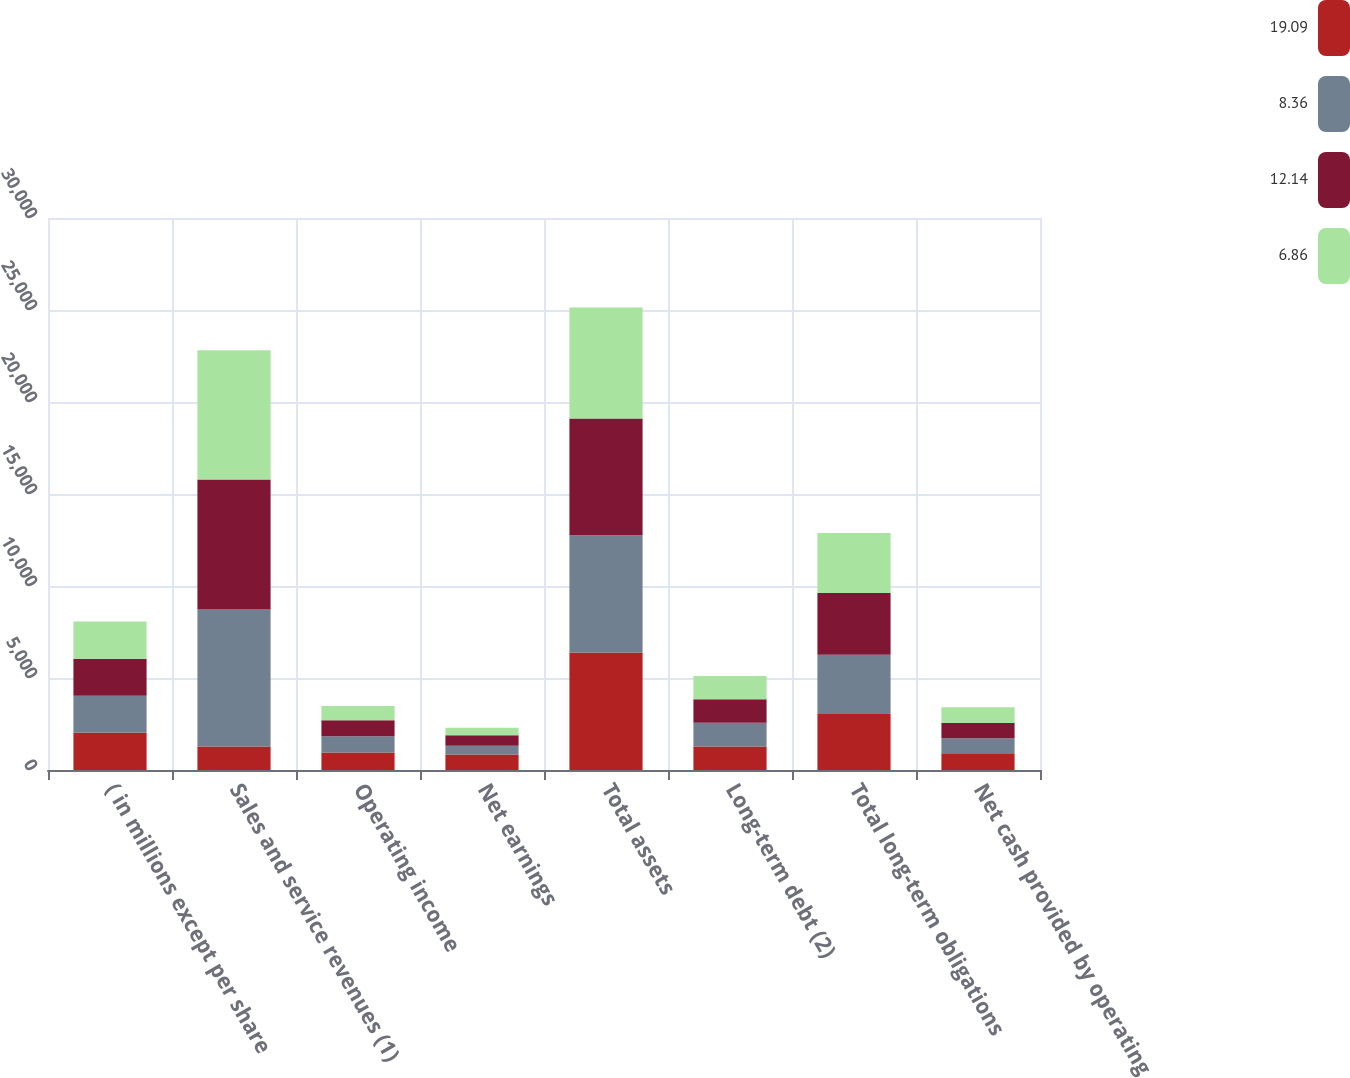<chart> <loc_0><loc_0><loc_500><loc_500><stacked_bar_chart><ecel><fcel>( in millions except per share<fcel>Sales and service revenues (1)<fcel>Operating income<fcel>Net earnings<fcel>Total assets<fcel>Long-term debt (2)<fcel>Total long-term obligations<fcel>Net cash provided by operating<nl><fcel>19.09<fcel>2018<fcel>1283<fcel>951<fcel>836<fcel>6383<fcel>1283<fcel>3038<fcel>914<nl><fcel>8.36<fcel>2017<fcel>7441<fcel>881<fcel>479<fcel>6374<fcel>1279<fcel>3225<fcel>814<nl><fcel>12.14<fcel>2016<fcel>7068<fcel>876<fcel>573<fcel>6352<fcel>1278<fcel>3356<fcel>822<nl><fcel>6.86<fcel>2015<fcel>7020<fcel>774<fcel>404<fcel>6024<fcel>1273<fcel>3260<fcel>861<nl></chart> 